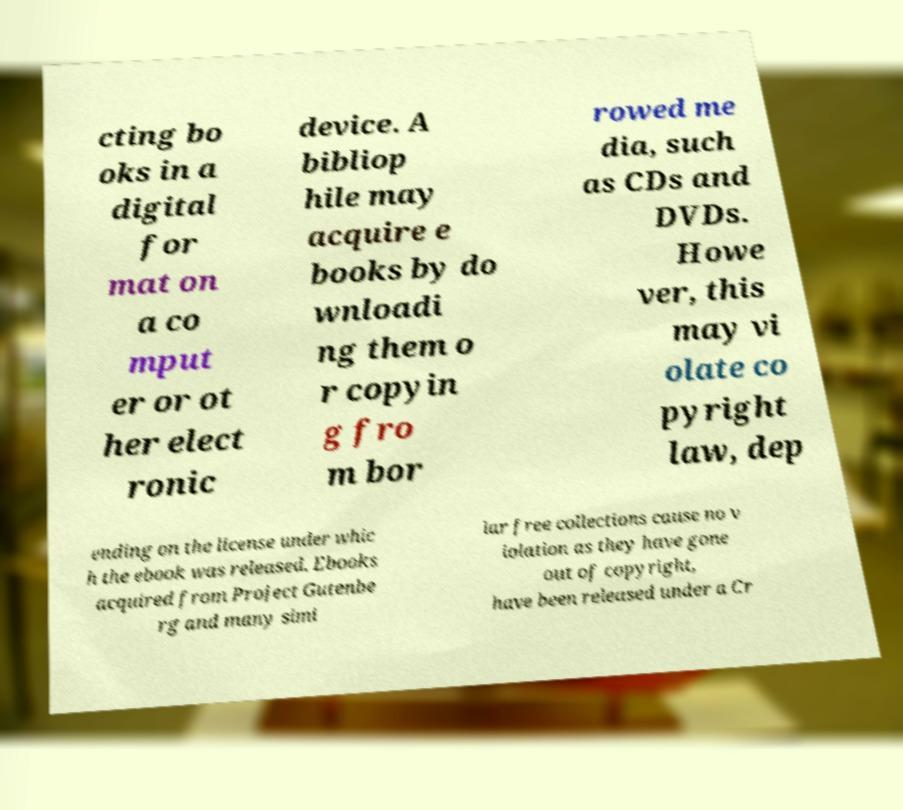Please identify and transcribe the text found in this image. cting bo oks in a digital for mat on a co mput er or ot her elect ronic device. A bibliop hile may acquire e books by do wnloadi ng them o r copyin g fro m bor rowed me dia, such as CDs and DVDs. Howe ver, this may vi olate co pyright law, dep ending on the license under whic h the ebook was released. Ebooks acquired from Project Gutenbe rg and many simi lar free collections cause no v iolation as they have gone out of copyright, have been released under a Cr 